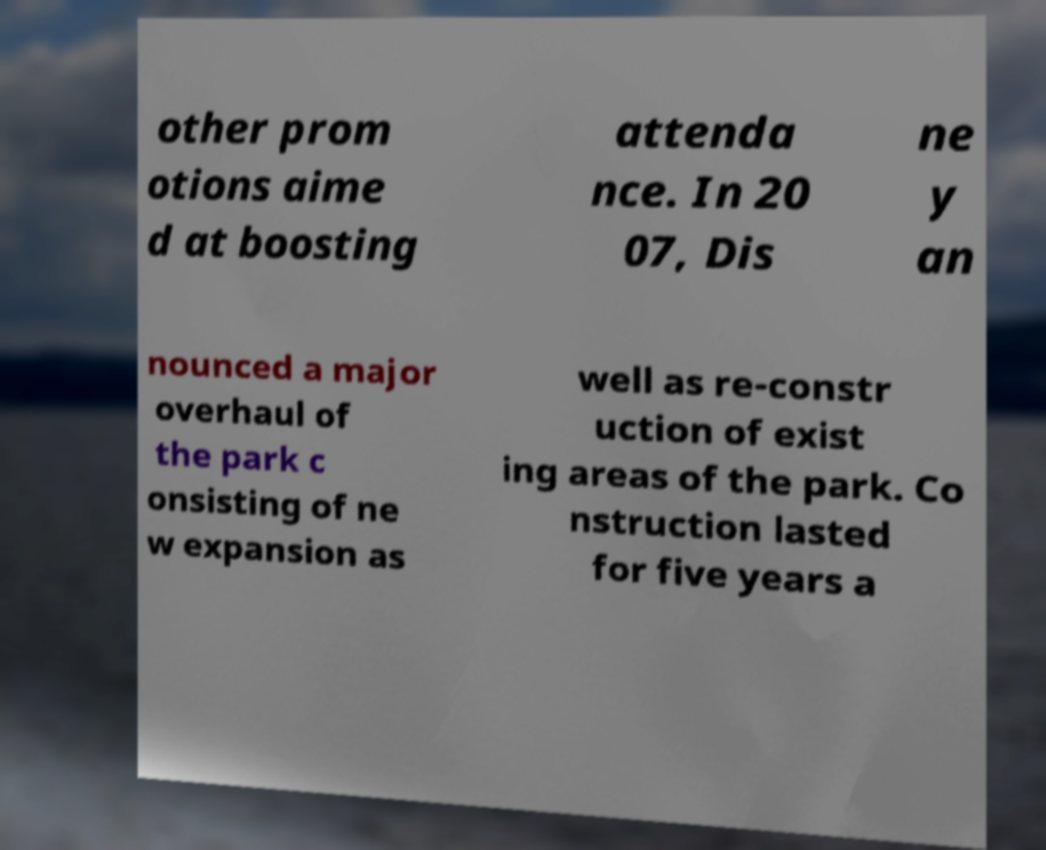Please read and relay the text visible in this image. What does it say? other prom otions aime d at boosting attenda nce. In 20 07, Dis ne y an nounced a major overhaul of the park c onsisting of ne w expansion as well as re-constr uction of exist ing areas of the park. Co nstruction lasted for five years a 